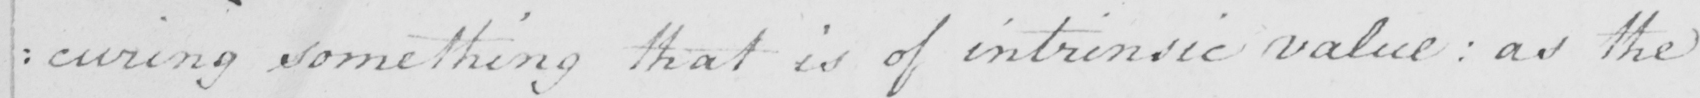Please transcribe the handwritten text in this image. : curing something that is of intrinsic value  :  as the 